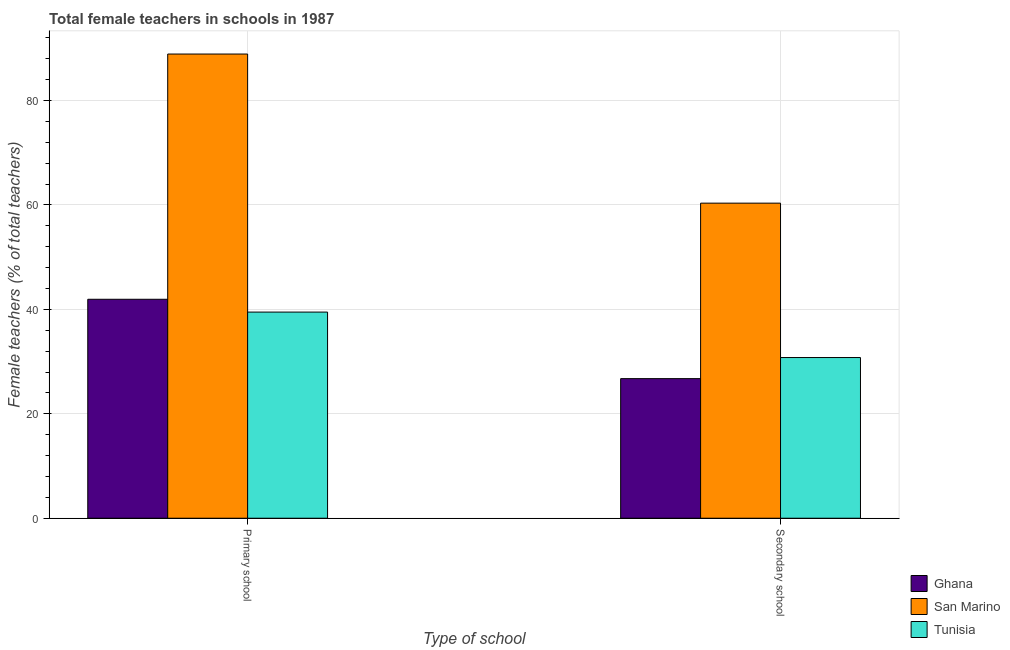What is the label of the 2nd group of bars from the left?
Provide a succinct answer. Secondary school. What is the percentage of female teachers in primary schools in San Marino?
Provide a short and direct response. 88.89. Across all countries, what is the maximum percentage of female teachers in primary schools?
Make the answer very short. 88.89. Across all countries, what is the minimum percentage of female teachers in primary schools?
Give a very brief answer. 39.47. In which country was the percentage of female teachers in primary schools maximum?
Your answer should be very brief. San Marino. In which country was the percentage of female teachers in secondary schools minimum?
Your response must be concise. Ghana. What is the total percentage of female teachers in primary schools in the graph?
Give a very brief answer. 170.29. What is the difference between the percentage of female teachers in primary schools in Tunisia and that in Ghana?
Offer a terse response. -2.46. What is the difference between the percentage of female teachers in secondary schools in Ghana and the percentage of female teachers in primary schools in Tunisia?
Your response must be concise. -12.74. What is the average percentage of female teachers in secondary schools per country?
Offer a very short reply. 39.28. What is the difference between the percentage of female teachers in primary schools and percentage of female teachers in secondary schools in San Marino?
Give a very brief answer. 28.55. In how many countries, is the percentage of female teachers in secondary schools greater than 32 %?
Make the answer very short. 1. What is the ratio of the percentage of female teachers in primary schools in San Marino to that in Ghana?
Make the answer very short. 2.12. In how many countries, is the percentage of female teachers in primary schools greater than the average percentage of female teachers in primary schools taken over all countries?
Offer a terse response. 1. What does the 3rd bar from the left in Secondary school represents?
Offer a very short reply. Tunisia. What does the 2nd bar from the right in Primary school represents?
Offer a terse response. San Marino. How many countries are there in the graph?
Your response must be concise. 3. What is the difference between two consecutive major ticks on the Y-axis?
Offer a very short reply. 20. Does the graph contain any zero values?
Offer a terse response. No. What is the title of the graph?
Make the answer very short. Total female teachers in schools in 1987. What is the label or title of the X-axis?
Ensure brevity in your answer.  Type of school. What is the label or title of the Y-axis?
Offer a very short reply. Female teachers (% of total teachers). What is the Female teachers (% of total teachers) in Ghana in Primary school?
Offer a terse response. 41.93. What is the Female teachers (% of total teachers) in San Marino in Primary school?
Your answer should be compact. 88.89. What is the Female teachers (% of total teachers) in Tunisia in Primary school?
Your answer should be compact. 39.47. What is the Female teachers (% of total teachers) of Ghana in Secondary school?
Offer a terse response. 26.73. What is the Female teachers (% of total teachers) in San Marino in Secondary school?
Provide a short and direct response. 60.34. What is the Female teachers (% of total teachers) in Tunisia in Secondary school?
Make the answer very short. 30.77. Across all Type of school, what is the maximum Female teachers (% of total teachers) in Ghana?
Keep it short and to the point. 41.93. Across all Type of school, what is the maximum Female teachers (% of total teachers) of San Marino?
Provide a succinct answer. 88.89. Across all Type of school, what is the maximum Female teachers (% of total teachers) in Tunisia?
Make the answer very short. 39.47. Across all Type of school, what is the minimum Female teachers (% of total teachers) of Ghana?
Keep it short and to the point. 26.73. Across all Type of school, what is the minimum Female teachers (% of total teachers) in San Marino?
Your answer should be compact. 60.34. Across all Type of school, what is the minimum Female teachers (% of total teachers) in Tunisia?
Provide a succinct answer. 30.77. What is the total Female teachers (% of total teachers) in Ghana in the graph?
Offer a very short reply. 68.66. What is the total Female teachers (% of total teachers) of San Marino in the graph?
Ensure brevity in your answer.  149.22. What is the total Female teachers (% of total teachers) of Tunisia in the graph?
Your answer should be very brief. 70.24. What is the difference between the Female teachers (% of total teachers) in Ghana in Primary school and that in Secondary school?
Provide a succinct answer. 15.2. What is the difference between the Female teachers (% of total teachers) of San Marino in Primary school and that in Secondary school?
Provide a short and direct response. 28.55. What is the difference between the Female teachers (% of total teachers) of Tunisia in Primary school and that in Secondary school?
Make the answer very short. 8.7. What is the difference between the Female teachers (% of total teachers) of Ghana in Primary school and the Female teachers (% of total teachers) of San Marino in Secondary school?
Your response must be concise. -18.41. What is the difference between the Female teachers (% of total teachers) in Ghana in Primary school and the Female teachers (% of total teachers) in Tunisia in Secondary school?
Your answer should be very brief. 11.16. What is the difference between the Female teachers (% of total teachers) in San Marino in Primary school and the Female teachers (% of total teachers) in Tunisia in Secondary school?
Ensure brevity in your answer.  58.12. What is the average Female teachers (% of total teachers) of Ghana per Type of school?
Offer a very short reply. 34.33. What is the average Female teachers (% of total teachers) in San Marino per Type of school?
Provide a short and direct response. 74.61. What is the average Female teachers (% of total teachers) of Tunisia per Type of school?
Provide a succinct answer. 35.12. What is the difference between the Female teachers (% of total teachers) of Ghana and Female teachers (% of total teachers) of San Marino in Primary school?
Make the answer very short. -46.96. What is the difference between the Female teachers (% of total teachers) of Ghana and Female teachers (% of total teachers) of Tunisia in Primary school?
Ensure brevity in your answer.  2.46. What is the difference between the Female teachers (% of total teachers) of San Marino and Female teachers (% of total teachers) of Tunisia in Primary school?
Provide a succinct answer. 49.42. What is the difference between the Female teachers (% of total teachers) in Ghana and Female teachers (% of total teachers) in San Marino in Secondary school?
Ensure brevity in your answer.  -33.6. What is the difference between the Female teachers (% of total teachers) in Ghana and Female teachers (% of total teachers) in Tunisia in Secondary school?
Give a very brief answer. -4.04. What is the difference between the Female teachers (% of total teachers) in San Marino and Female teachers (% of total teachers) in Tunisia in Secondary school?
Ensure brevity in your answer.  29.57. What is the ratio of the Female teachers (% of total teachers) in Ghana in Primary school to that in Secondary school?
Give a very brief answer. 1.57. What is the ratio of the Female teachers (% of total teachers) in San Marino in Primary school to that in Secondary school?
Keep it short and to the point. 1.47. What is the ratio of the Female teachers (% of total teachers) of Tunisia in Primary school to that in Secondary school?
Your response must be concise. 1.28. What is the difference between the highest and the second highest Female teachers (% of total teachers) of Ghana?
Your answer should be compact. 15.2. What is the difference between the highest and the second highest Female teachers (% of total teachers) in San Marino?
Your response must be concise. 28.55. What is the difference between the highest and the second highest Female teachers (% of total teachers) in Tunisia?
Offer a terse response. 8.7. What is the difference between the highest and the lowest Female teachers (% of total teachers) of Ghana?
Provide a succinct answer. 15.2. What is the difference between the highest and the lowest Female teachers (% of total teachers) of San Marino?
Your response must be concise. 28.55. What is the difference between the highest and the lowest Female teachers (% of total teachers) of Tunisia?
Make the answer very short. 8.7. 